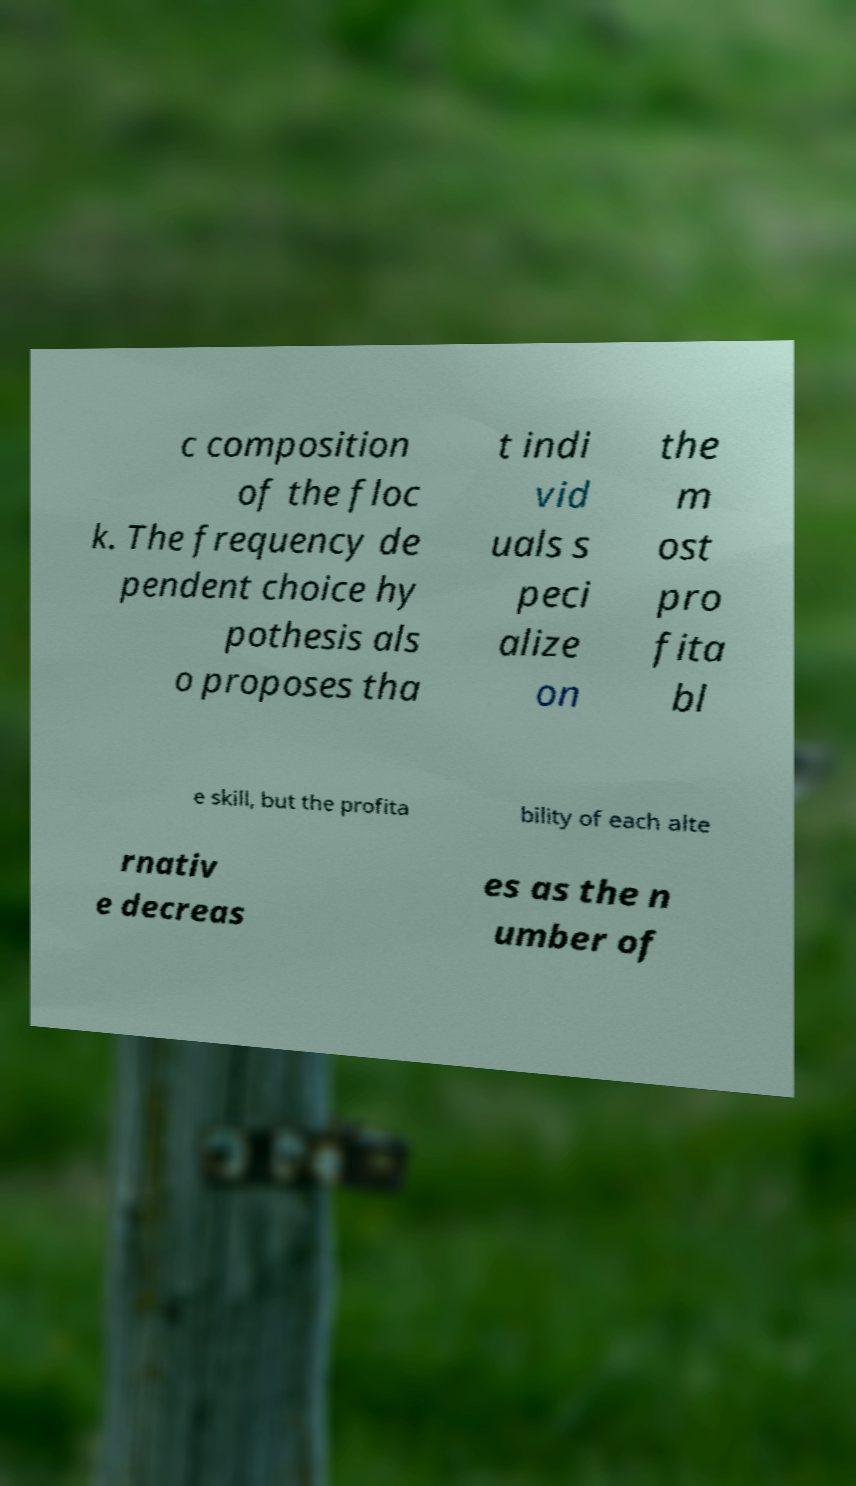Could you assist in decoding the text presented in this image and type it out clearly? c composition of the floc k. The frequency de pendent choice hy pothesis als o proposes tha t indi vid uals s peci alize on the m ost pro fita bl e skill, but the profita bility of each alte rnativ e decreas es as the n umber of 